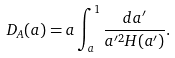Convert formula to latex. <formula><loc_0><loc_0><loc_500><loc_500>D _ { A } ( a ) = a \int _ { a } ^ { 1 } \frac { d a ^ { \prime } } { a ^ { \prime 2 } H ( a ^ { \prime } ) } .</formula> 